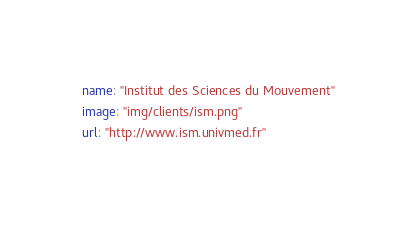<code> <loc_0><loc_0><loc_500><loc_500><_YAML_>name: "Institut des Sciences du Mouvement"
image: "img/clients/ism.png"
url: "http://www.ism.univmed.fr"
</code> 